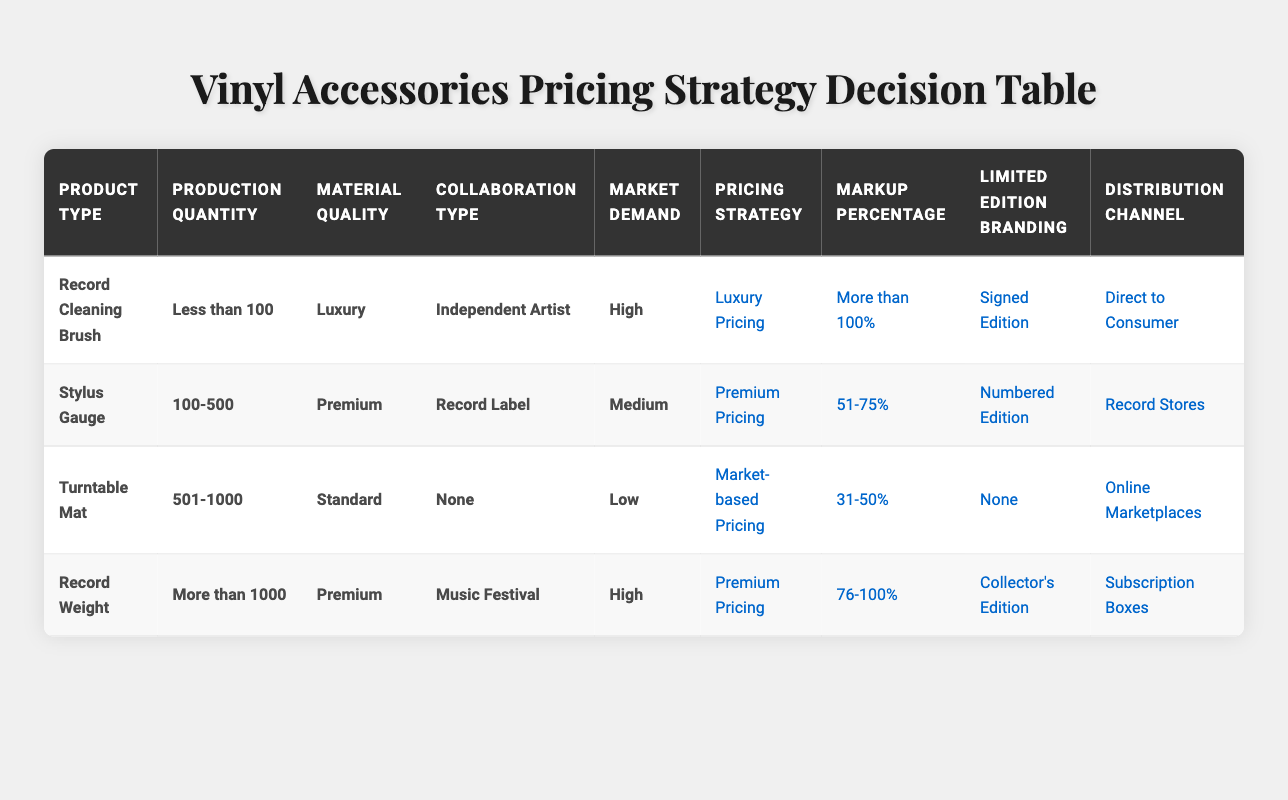What pricing strategy is suggested for a Record Cleaning Brush with high market demand? The table indicates that for a Record Cleaning Brush with high market demand, the pricing strategy is Luxury Pricing. This can be directly identified from the corresponding row in the table.
Answer: Luxury Pricing What is the markup percentage for a Stylus Gauge that is produced in a quantity of 100-500? According to the table, a Stylus Gauge with a production quantity of 100-500 has a markup percentage of 51-75%. This is taken from the relevant row where these conditions align.
Answer: 51-75% Does the Turntable Mat have any limited edition branding? Yes, the table states that for a Turntable Mat produced in the quantity range of 501-1000 and with low market demand, the limited edition branding is marked as None. This confirms there is no branding for this product type under these conditions.
Answer: No What is the distribution channel for a Record Weight produced in quantities greater than 1000? The table shows that a Record Weight produced in quantities greater than 1000 is distributed through Subscription Boxes. This can be found by checking the relevant conditions and their corresponding actions in the table.
Answer: Subscription Boxes If I combine the marked conditions where Material Quality is Premium and Market Demand is High, what are the pricing strategy options? The relevant rows in the table show that there are two products that fit these criteria: the Record Weight and the Stylus Gauge. For Record Weight, the pricing strategy is Premium Pricing, while for Stylus Gauge, it is Premium Pricing. Since both yield the same pricing strategy option of Premium Pricing, that is the answer.
Answer: Premium Pricing What is the average markup percentage for products with Standard material quality? Only one product fits this category in the table, which is the Turntable Mat, having a markup percentage of 31-50%. Hence, the average markup percentage is simply that value since it is the only data point.
Answer: 31-50% Is it true that products with high market demand always have luxury pricing? No, examining the table shows that while high market demand does lead to Luxury Pricing for the Record Cleaning Brush, it results in Premium Pricing for the Record Weight. Therefore, not all high-demand products align with luxury pricing.
Answer: No What limited edition branding is used for Vinyl Accessories that are made in less than 100 quantities and have a luxury material? The table indicates that for a Record Cleaning Brush produced in less than 100 quantities with luxury material, it uses Signed Edition branding. This is directly observable in the corresponding row for those conditions.
Answer: Signed Edition 